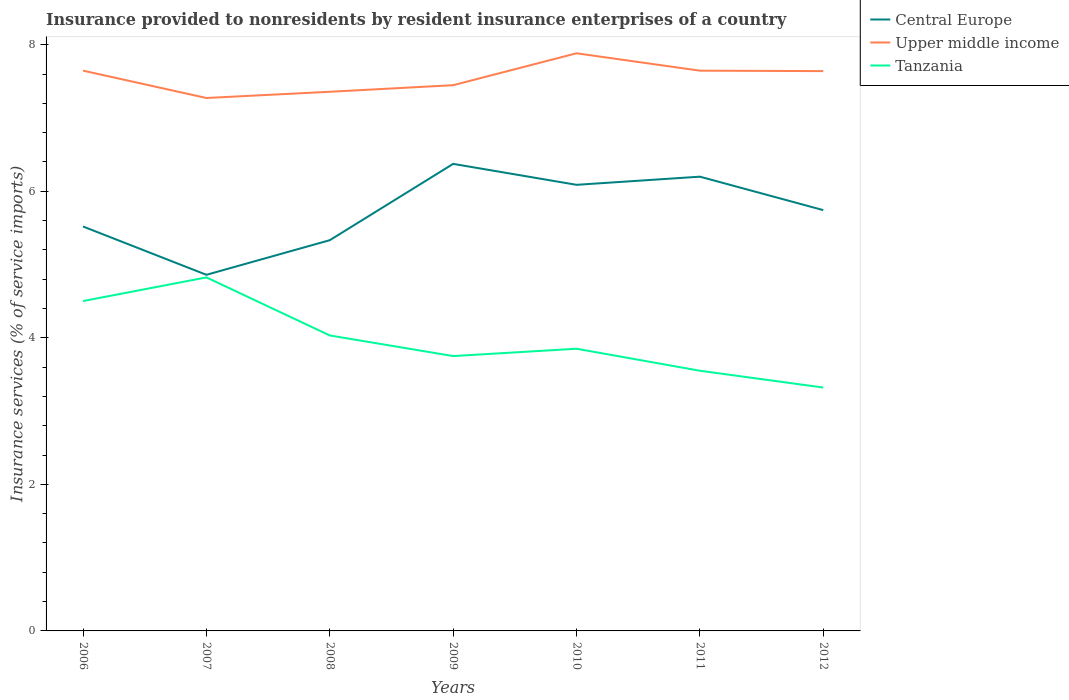How many different coloured lines are there?
Ensure brevity in your answer.  3. Is the number of lines equal to the number of legend labels?
Offer a very short reply. Yes. Across all years, what is the maximum insurance provided to nonresidents in Tanzania?
Offer a very short reply. 3.32. What is the total insurance provided to nonresidents in Upper middle income in the graph?
Give a very brief answer. -0.37. What is the difference between the highest and the second highest insurance provided to nonresidents in Upper middle income?
Your answer should be compact. 0.61. What is the difference between the highest and the lowest insurance provided to nonresidents in Upper middle income?
Provide a short and direct response. 4. How many years are there in the graph?
Make the answer very short. 7. Does the graph contain grids?
Offer a terse response. No. How many legend labels are there?
Provide a succinct answer. 3. How are the legend labels stacked?
Your answer should be compact. Vertical. What is the title of the graph?
Give a very brief answer. Insurance provided to nonresidents by resident insurance enterprises of a country. Does "Central Europe" appear as one of the legend labels in the graph?
Provide a short and direct response. Yes. What is the label or title of the X-axis?
Your answer should be very brief. Years. What is the label or title of the Y-axis?
Offer a terse response. Insurance services (% of service imports). What is the Insurance services (% of service imports) in Central Europe in 2006?
Keep it short and to the point. 5.52. What is the Insurance services (% of service imports) in Upper middle income in 2006?
Offer a terse response. 7.65. What is the Insurance services (% of service imports) in Tanzania in 2006?
Provide a short and direct response. 4.5. What is the Insurance services (% of service imports) of Central Europe in 2007?
Your response must be concise. 4.86. What is the Insurance services (% of service imports) of Upper middle income in 2007?
Ensure brevity in your answer.  7.27. What is the Insurance services (% of service imports) in Tanzania in 2007?
Ensure brevity in your answer.  4.82. What is the Insurance services (% of service imports) in Central Europe in 2008?
Give a very brief answer. 5.33. What is the Insurance services (% of service imports) of Upper middle income in 2008?
Ensure brevity in your answer.  7.36. What is the Insurance services (% of service imports) in Tanzania in 2008?
Your answer should be compact. 4.03. What is the Insurance services (% of service imports) in Central Europe in 2009?
Offer a terse response. 6.37. What is the Insurance services (% of service imports) of Upper middle income in 2009?
Give a very brief answer. 7.45. What is the Insurance services (% of service imports) of Tanzania in 2009?
Provide a succinct answer. 3.75. What is the Insurance services (% of service imports) in Central Europe in 2010?
Offer a very short reply. 6.09. What is the Insurance services (% of service imports) of Upper middle income in 2010?
Give a very brief answer. 7.88. What is the Insurance services (% of service imports) of Tanzania in 2010?
Offer a very short reply. 3.85. What is the Insurance services (% of service imports) of Central Europe in 2011?
Ensure brevity in your answer.  6.2. What is the Insurance services (% of service imports) in Upper middle income in 2011?
Offer a terse response. 7.65. What is the Insurance services (% of service imports) in Tanzania in 2011?
Your answer should be compact. 3.55. What is the Insurance services (% of service imports) in Central Europe in 2012?
Provide a short and direct response. 5.74. What is the Insurance services (% of service imports) of Upper middle income in 2012?
Offer a very short reply. 7.64. What is the Insurance services (% of service imports) in Tanzania in 2012?
Give a very brief answer. 3.32. Across all years, what is the maximum Insurance services (% of service imports) in Central Europe?
Provide a succinct answer. 6.37. Across all years, what is the maximum Insurance services (% of service imports) of Upper middle income?
Ensure brevity in your answer.  7.88. Across all years, what is the maximum Insurance services (% of service imports) in Tanzania?
Provide a succinct answer. 4.82. Across all years, what is the minimum Insurance services (% of service imports) in Central Europe?
Provide a short and direct response. 4.86. Across all years, what is the minimum Insurance services (% of service imports) of Upper middle income?
Your answer should be compact. 7.27. Across all years, what is the minimum Insurance services (% of service imports) in Tanzania?
Your answer should be very brief. 3.32. What is the total Insurance services (% of service imports) of Central Europe in the graph?
Offer a very short reply. 40.11. What is the total Insurance services (% of service imports) in Upper middle income in the graph?
Offer a very short reply. 52.89. What is the total Insurance services (% of service imports) in Tanzania in the graph?
Offer a very short reply. 27.83. What is the difference between the Insurance services (% of service imports) of Central Europe in 2006 and that in 2007?
Keep it short and to the point. 0.66. What is the difference between the Insurance services (% of service imports) in Upper middle income in 2006 and that in 2007?
Your answer should be very brief. 0.37. What is the difference between the Insurance services (% of service imports) of Tanzania in 2006 and that in 2007?
Offer a very short reply. -0.32. What is the difference between the Insurance services (% of service imports) of Central Europe in 2006 and that in 2008?
Your answer should be very brief. 0.19. What is the difference between the Insurance services (% of service imports) in Upper middle income in 2006 and that in 2008?
Provide a succinct answer. 0.29. What is the difference between the Insurance services (% of service imports) in Tanzania in 2006 and that in 2008?
Offer a very short reply. 0.47. What is the difference between the Insurance services (% of service imports) in Central Europe in 2006 and that in 2009?
Keep it short and to the point. -0.85. What is the difference between the Insurance services (% of service imports) of Upper middle income in 2006 and that in 2009?
Provide a short and direct response. 0.2. What is the difference between the Insurance services (% of service imports) in Tanzania in 2006 and that in 2009?
Give a very brief answer. 0.75. What is the difference between the Insurance services (% of service imports) of Central Europe in 2006 and that in 2010?
Your answer should be compact. -0.57. What is the difference between the Insurance services (% of service imports) of Upper middle income in 2006 and that in 2010?
Your answer should be compact. -0.24. What is the difference between the Insurance services (% of service imports) of Tanzania in 2006 and that in 2010?
Offer a terse response. 0.65. What is the difference between the Insurance services (% of service imports) in Central Europe in 2006 and that in 2011?
Your response must be concise. -0.68. What is the difference between the Insurance services (% of service imports) of Tanzania in 2006 and that in 2011?
Your answer should be compact. 0.95. What is the difference between the Insurance services (% of service imports) in Central Europe in 2006 and that in 2012?
Make the answer very short. -0.22. What is the difference between the Insurance services (% of service imports) of Upper middle income in 2006 and that in 2012?
Make the answer very short. 0.01. What is the difference between the Insurance services (% of service imports) in Tanzania in 2006 and that in 2012?
Ensure brevity in your answer.  1.18. What is the difference between the Insurance services (% of service imports) in Central Europe in 2007 and that in 2008?
Keep it short and to the point. -0.47. What is the difference between the Insurance services (% of service imports) of Upper middle income in 2007 and that in 2008?
Your response must be concise. -0.09. What is the difference between the Insurance services (% of service imports) of Tanzania in 2007 and that in 2008?
Provide a succinct answer. 0.79. What is the difference between the Insurance services (% of service imports) in Central Europe in 2007 and that in 2009?
Ensure brevity in your answer.  -1.51. What is the difference between the Insurance services (% of service imports) in Upper middle income in 2007 and that in 2009?
Your answer should be compact. -0.17. What is the difference between the Insurance services (% of service imports) in Tanzania in 2007 and that in 2009?
Your answer should be compact. 1.07. What is the difference between the Insurance services (% of service imports) in Central Europe in 2007 and that in 2010?
Provide a succinct answer. -1.23. What is the difference between the Insurance services (% of service imports) of Upper middle income in 2007 and that in 2010?
Ensure brevity in your answer.  -0.61. What is the difference between the Insurance services (% of service imports) of Tanzania in 2007 and that in 2010?
Your answer should be compact. 0.97. What is the difference between the Insurance services (% of service imports) of Central Europe in 2007 and that in 2011?
Provide a succinct answer. -1.34. What is the difference between the Insurance services (% of service imports) of Upper middle income in 2007 and that in 2011?
Your answer should be very brief. -0.37. What is the difference between the Insurance services (% of service imports) in Tanzania in 2007 and that in 2011?
Your answer should be very brief. 1.27. What is the difference between the Insurance services (% of service imports) in Central Europe in 2007 and that in 2012?
Make the answer very short. -0.88. What is the difference between the Insurance services (% of service imports) of Upper middle income in 2007 and that in 2012?
Keep it short and to the point. -0.37. What is the difference between the Insurance services (% of service imports) of Tanzania in 2007 and that in 2012?
Offer a terse response. 1.5. What is the difference between the Insurance services (% of service imports) in Central Europe in 2008 and that in 2009?
Give a very brief answer. -1.04. What is the difference between the Insurance services (% of service imports) in Upper middle income in 2008 and that in 2009?
Provide a succinct answer. -0.09. What is the difference between the Insurance services (% of service imports) in Tanzania in 2008 and that in 2009?
Keep it short and to the point. 0.28. What is the difference between the Insurance services (% of service imports) of Central Europe in 2008 and that in 2010?
Your answer should be compact. -0.76. What is the difference between the Insurance services (% of service imports) of Upper middle income in 2008 and that in 2010?
Offer a terse response. -0.53. What is the difference between the Insurance services (% of service imports) of Tanzania in 2008 and that in 2010?
Provide a short and direct response. 0.18. What is the difference between the Insurance services (% of service imports) of Central Europe in 2008 and that in 2011?
Keep it short and to the point. -0.87. What is the difference between the Insurance services (% of service imports) in Upper middle income in 2008 and that in 2011?
Give a very brief answer. -0.29. What is the difference between the Insurance services (% of service imports) of Tanzania in 2008 and that in 2011?
Provide a succinct answer. 0.48. What is the difference between the Insurance services (% of service imports) in Central Europe in 2008 and that in 2012?
Provide a succinct answer. -0.41. What is the difference between the Insurance services (% of service imports) in Upper middle income in 2008 and that in 2012?
Provide a succinct answer. -0.28. What is the difference between the Insurance services (% of service imports) in Tanzania in 2008 and that in 2012?
Your answer should be compact. 0.71. What is the difference between the Insurance services (% of service imports) in Central Europe in 2009 and that in 2010?
Provide a short and direct response. 0.29. What is the difference between the Insurance services (% of service imports) of Upper middle income in 2009 and that in 2010?
Your answer should be compact. -0.44. What is the difference between the Insurance services (% of service imports) in Central Europe in 2009 and that in 2011?
Give a very brief answer. 0.17. What is the difference between the Insurance services (% of service imports) in Upper middle income in 2009 and that in 2011?
Offer a terse response. -0.2. What is the difference between the Insurance services (% of service imports) of Tanzania in 2009 and that in 2011?
Your response must be concise. 0.2. What is the difference between the Insurance services (% of service imports) of Central Europe in 2009 and that in 2012?
Your answer should be very brief. 0.63. What is the difference between the Insurance services (% of service imports) in Upper middle income in 2009 and that in 2012?
Offer a terse response. -0.19. What is the difference between the Insurance services (% of service imports) of Tanzania in 2009 and that in 2012?
Your answer should be very brief. 0.43. What is the difference between the Insurance services (% of service imports) in Central Europe in 2010 and that in 2011?
Offer a very short reply. -0.11. What is the difference between the Insurance services (% of service imports) of Upper middle income in 2010 and that in 2011?
Offer a very short reply. 0.24. What is the difference between the Insurance services (% of service imports) of Tanzania in 2010 and that in 2011?
Provide a succinct answer. 0.3. What is the difference between the Insurance services (% of service imports) of Central Europe in 2010 and that in 2012?
Offer a very short reply. 0.35. What is the difference between the Insurance services (% of service imports) in Upper middle income in 2010 and that in 2012?
Offer a terse response. 0.24. What is the difference between the Insurance services (% of service imports) in Tanzania in 2010 and that in 2012?
Keep it short and to the point. 0.53. What is the difference between the Insurance services (% of service imports) in Central Europe in 2011 and that in 2012?
Your response must be concise. 0.46. What is the difference between the Insurance services (% of service imports) of Upper middle income in 2011 and that in 2012?
Your answer should be very brief. 0.01. What is the difference between the Insurance services (% of service imports) in Tanzania in 2011 and that in 2012?
Provide a short and direct response. 0.23. What is the difference between the Insurance services (% of service imports) of Central Europe in 2006 and the Insurance services (% of service imports) of Upper middle income in 2007?
Provide a short and direct response. -1.75. What is the difference between the Insurance services (% of service imports) in Central Europe in 2006 and the Insurance services (% of service imports) in Tanzania in 2007?
Provide a short and direct response. 0.69. What is the difference between the Insurance services (% of service imports) in Upper middle income in 2006 and the Insurance services (% of service imports) in Tanzania in 2007?
Give a very brief answer. 2.82. What is the difference between the Insurance services (% of service imports) in Central Europe in 2006 and the Insurance services (% of service imports) in Upper middle income in 2008?
Ensure brevity in your answer.  -1.84. What is the difference between the Insurance services (% of service imports) of Central Europe in 2006 and the Insurance services (% of service imports) of Tanzania in 2008?
Ensure brevity in your answer.  1.49. What is the difference between the Insurance services (% of service imports) in Upper middle income in 2006 and the Insurance services (% of service imports) in Tanzania in 2008?
Your answer should be compact. 3.61. What is the difference between the Insurance services (% of service imports) of Central Europe in 2006 and the Insurance services (% of service imports) of Upper middle income in 2009?
Your response must be concise. -1.93. What is the difference between the Insurance services (% of service imports) in Central Europe in 2006 and the Insurance services (% of service imports) in Tanzania in 2009?
Your answer should be very brief. 1.77. What is the difference between the Insurance services (% of service imports) in Upper middle income in 2006 and the Insurance services (% of service imports) in Tanzania in 2009?
Your response must be concise. 3.9. What is the difference between the Insurance services (% of service imports) in Central Europe in 2006 and the Insurance services (% of service imports) in Upper middle income in 2010?
Provide a succinct answer. -2.36. What is the difference between the Insurance services (% of service imports) in Central Europe in 2006 and the Insurance services (% of service imports) in Tanzania in 2010?
Provide a short and direct response. 1.67. What is the difference between the Insurance services (% of service imports) of Upper middle income in 2006 and the Insurance services (% of service imports) of Tanzania in 2010?
Provide a succinct answer. 3.79. What is the difference between the Insurance services (% of service imports) in Central Europe in 2006 and the Insurance services (% of service imports) in Upper middle income in 2011?
Provide a succinct answer. -2.13. What is the difference between the Insurance services (% of service imports) of Central Europe in 2006 and the Insurance services (% of service imports) of Tanzania in 2011?
Provide a succinct answer. 1.97. What is the difference between the Insurance services (% of service imports) of Upper middle income in 2006 and the Insurance services (% of service imports) of Tanzania in 2011?
Provide a succinct answer. 4.1. What is the difference between the Insurance services (% of service imports) of Central Europe in 2006 and the Insurance services (% of service imports) of Upper middle income in 2012?
Offer a very short reply. -2.12. What is the difference between the Insurance services (% of service imports) in Central Europe in 2006 and the Insurance services (% of service imports) in Tanzania in 2012?
Your answer should be very brief. 2.2. What is the difference between the Insurance services (% of service imports) in Upper middle income in 2006 and the Insurance services (% of service imports) in Tanzania in 2012?
Offer a terse response. 4.32. What is the difference between the Insurance services (% of service imports) of Central Europe in 2007 and the Insurance services (% of service imports) of Upper middle income in 2008?
Offer a terse response. -2.5. What is the difference between the Insurance services (% of service imports) of Central Europe in 2007 and the Insurance services (% of service imports) of Tanzania in 2008?
Provide a succinct answer. 0.83. What is the difference between the Insurance services (% of service imports) of Upper middle income in 2007 and the Insurance services (% of service imports) of Tanzania in 2008?
Keep it short and to the point. 3.24. What is the difference between the Insurance services (% of service imports) of Central Europe in 2007 and the Insurance services (% of service imports) of Upper middle income in 2009?
Provide a succinct answer. -2.59. What is the difference between the Insurance services (% of service imports) of Central Europe in 2007 and the Insurance services (% of service imports) of Tanzania in 2009?
Offer a terse response. 1.11. What is the difference between the Insurance services (% of service imports) of Upper middle income in 2007 and the Insurance services (% of service imports) of Tanzania in 2009?
Offer a very short reply. 3.52. What is the difference between the Insurance services (% of service imports) of Central Europe in 2007 and the Insurance services (% of service imports) of Upper middle income in 2010?
Provide a short and direct response. -3.02. What is the difference between the Insurance services (% of service imports) in Central Europe in 2007 and the Insurance services (% of service imports) in Tanzania in 2010?
Offer a very short reply. 1.01. What is the difference between the Insurance services (% of service imports) of Upper middle income in 2007 and the Insurance services (% of service imports) of Tanzania in 2010?
Your answer should be compact. 3.42. What is the difference between the Insurance services (% of service imports) of Central Europe in 2007 and the Insurance services (% of service imports) of Upper middle income in 2011?
Keep it short and to the point. -2.79. What is the difference between the Insurance services (% of service imports) of Central Europe in 2007 and the Insurance services (% of service imports) of Tanzania in 2011?
Offer a terse response. 1.31. What is the difference between the Insurance services (% of service imports) in Upper middle income in 2007 and the Insurance services (% of service imports) in Tanzania in 2011?
Your answer should be very brief. 3.72. What is the difference between the Insurance services (% of service imports) in Central Europe in 2007 and the Insurance services (% of service imports) in Upper middle income in 2012?
Your response must be concise. -2.78. What is the difference between the Insurance services (% of service imports) of Central Europe in 2007 and the Insurance services (% of service imports) of Tanzania in 2012?
Make the answer very short. 1.54. What is the difference between the Insurance services (% of service imports) in Upper middle income in 2007 and the Insurance services (% of service imports) in Tanzania in 2012?
Your answer should be very brief. 3.95. What is the difference between the Insurance services (% of service imports) of Central Europe in 2008 and the Insurance services (% of service imports) of Upper middle income in 2009?
Your answer should be compact. -2.12. What is the difference between the Insurance services (% of service imports) of Central Europe in 2008 and the Insurance services (% of service imports) of Tanzania in 2009?
Provide a short and direct response. 1.58. What is the difference between the Insurance services (% of service imports) of Upper middle income in 2008 and the Insurance services (% of service imports) of Tanzania in 2009?
Provide a succinct answer. 3.61. What is the difference between the Insurance services (% of service imports) in Central Europe in 2008 and the Insurance services (% of service imports) in Upper middle income in 2010?
Offer a terse response. -2.55. What is the difference between the Insurance services (% of service imports) of Central Europe in 2008 and the Insurance services (% of service imports) of Tanzania in 2010?
Provide a succinct answer. 1.48. What is the difference between the Insurance services (% of service imports) of Upper middle income in 2008 and the Insurance services (% of service imports) of Tanzania in 2010?
Your answer should be compact. 3.51. What is the difference between the Insurance services (% of service imports) of Central Europe in 2008 and the Insurance services (% of service imports) of Upper middle income in 2011?
Your answer should be compact. -2.31. What is the difference between the Insurance services (% of service imports) in Central Europe in 2008 and the Insurance services (% of service imports) in Tanzania in 2011?
Give a very brief answer. 1.78. What is the difference between the Insurance services (% of service imports) of Upper middle income in 2008 and the Insurance services (% of service imports) of Tanzania in 2011?
Your answer should be compact. 3.81. What is the difference between the Insurance services (% of service imports) in Central Europe in 2008 and the Insurance services (% of service imports) in Upper middle income in 2012?
Offer a very short reply. -2.31. What is the difference between the Insurance services (% of service imports) of Central Europe in 2008 and the Insurance services (% of service imports) of Tanzania in 2012?
Provide a short and direct response. 2.01. What is the difference between the Insurance services (% of service imports) of Upper middle income in 2008 and the Insurance services (% of service imports) of Tanzania in 2012?
Offer a terse response. 4.04. What is the difference between the Insurance services (% of service imports) in Central Europe in 2009 and the Insurance services (% of service imports) in Upper middle income in 2010?
Keep it short and to the point. -1.51. What is the difference between the Insurance services (% of service imports) of Central Europe in 2009 and the Insurance services (% of service imports) of Tanzania in 2010?
Provide a short and direct response. 2.52. What is the difference between the Insurance services (% of service imports) of Upper middle income in 2009 and the Insurance services (% of service imports) of Tanzania in 2010?
Your answer should be compact. 3.6. What is the difference between the Insurance services (% of service imports) of Central Europe in 2009 and the Insurance services (% of service imports) of Upper middle income in 2011?
Your response must be concise. -1.27. What is the difference between the Insurance services (% of service imports) in Central Europe in 2009 and the Insurance services (% of service imports) in Tanzania in 2011?
Your answer should be compact. 2.82. What is the difference between the Insurance services (% of service imports) of Upper middle income in 2009 and the Insurance services (% of service imports) of Tanzania in 2011?
Your response must be concise. 3.9. What is the difference between the Insurance services (% of service imports) of Central Europe in 2009 and the Insurance services (% of service imports) of Upper middle income in 2012?
Your response must be concise. -1.27. What is the difference between the Insurance services (% of service imports) in Central Europe in 2009 and the Insurance services (% of service imports) in Tanzania in 2012?
Ensure brevity in your answer.  3.05. What is the difference between the Insurance services (% of service imports) of Upper middle income in 2009 and the Insurance services (% of service imports) of Tanzania in 2012?
Give a very brief answer. 4.13. What is the difference between the Insurance services (% of service imports) in Central Europe in 2010 and the Insurance services (% of service imports) in Upper middle income in 2011?
Provide a short and direct response. -1.56. What is the difference between the Insurance services (% of service imports) of Central Europe in 2010 and the Insurance services (% of service imports) of Tanzania in 2011?
Offer a very short reply. 2.54. What is the difference between the Insurance services (% of service imports) in Upper middle income in 2010 and the Insurance services (% of service imports) in Tanzania in 2011?
Your answer should be very brief. 4.33. What is the difference between the Insurance services (% of service imports) in Central Europe in 2010 and the Insurance services (% of service imports) in Upper middle income in 2012?
Provide a succinct answer. -1.55. What is the difference between the Insurance services (% of service imports) in Central Europe in 2010 and the Insurance services (% of service imports) in Tanzania in 2012?
Offer a terse response. 2.77. What is the difference between the Insurance services (% of service imports) in Upper middle income in 2010 and the Insurance services (% of service imports) in Tanzania in 2012?
Provide a short and direct response. 4.56. What is the difference between the Insurance services (% of service imports) in Central Europe in 2011 and the Insurance services (% of service imports) in Upper middle income in 2012?
Ensure brevity in your answer.  -1.44. What is the difference between the Insurance services (% of service imports) of Central Europe in 2011 and the Insurance services (% of service imports) of Tanzania in 2012?
Your answer should be compact. 2.88. What is the difference between the Insurance services (% of service imports) in Upper middle income in 2011 and the Insurance services (% of service imports) in Tanzania in 2012?
Keep it short and to the point. 4.32. What is the average Insurance services (% of service imports) in Central Europe per year?
Ensure brevity in your answer.  5.73. What is the average Insurance services (% of service imports) of Upper middle income per year?
Provide a succinct answer. 7.56. What is the average Insurance services (% of service imports) in Tanzania per year?
Keep it short and to the point. 3.98. In the year 2006, what is the difference between the Insurance services (% of service imports) of Central Europe and Insurance services (% of service imports) of Upper middle income?
Your answer should be very brief. -2.13. In the year 2006, what is the difference between the Insurance services (% of service imports) of Central Europe and Insurance services (% of service imports) of Tanzania?
Your answer should be very brief. 1.02. In the year 2006, what is the difference between the Insurance services (% of service imports) in Upper middle income and Insurance services (% of service imports) in Tanzania?
Offer a very short reply. 3.14. In the year 2007, what is the difference between the Insurance services (% of service imports) in Central Europe and Insurance services (% of service imports) in Upper middle income?
Make the answer very short. -2.41. In the year 2007, what is the difference between the Insurance services (% of service imports) in Central Europe and Insurance services (% of service imports) in Tanzania?
Your response must be concise. 0.04. In the year 2007, what is the difference between the Insurance services (% of service imports) in Upper middle income and Insurance services (% of service imports) in Tanzania?
Ensure brevity in your answer.  2.45. In the year 2008, what is the difference between the Insurance services (% of service imports) of Central Europe and Insurance services (% of service imports) of Upper middle income?
Your answer should be compact. -2.03. In the year 2008, what is the difference between the Insurance services (% of service imports) in Central Europe and Insurance services (% of service imports) in Tanzania?
Your answer should be very brief. 1.3. In the year 2008, what is the difference between the Insurance services (% of service imports) in Upper middle income and Insurance services (% of service imports) in Tanzania?
Your response must be concise. 3.33. In the year 2009, what is the difference between the Insurance services (% of service imports) of Central Europe and Insurance services (% of service imports) of Upper middle income?
Your response must be concise. -1.07. In the year 2009, what is the difference between the Insurance services (% of service imports) of Central Europe and Insurance services (% of service imports) of Tanzania?
Your answer should be very brief. 2.62. In the year 2009, what is the difference between the Insurance services (% of service imports) in Upper middle income and Insurance services (% of service imports) in Tanzania?
Your answer should be compact. 3.7. In the year 2010, what is the difference between the Insurance services (% of service imports) in Central Europe and Insurance services (% of service imports) in Upper middle income?
Provide a short and direct response. -1.79. In the year 2010, what is the difference between the Insurance services (% of service imports) in Central Europe and Insurance services (% of service imports) in Tanzania?
Provide a short and direct response. 2.24. In the year 2010, what is the difference between the Insurance services (% of service imports) in Upper middle income and Insurance services (% of service imports) in Tanzania?
Offer a very short reply. 4.03. In the year 2011, what is the difference between the Insurance services (% of service imports) of Central Europe and Insurance services (% of service imports) of Upper middle income?
Make the answer very short. -1.45. In the year 2011, what is the difference between the Insurance services (% of service imports) in Central Europe and Insurance services (% of service imports) in Tanzania?
Make the answer very short. 2.65. In the year 2011, what is the difference between the Insurance services (% of service imports) in Upper middle income and Insurance services (% of service imports) in Tanzania?
Ensure brevity in your answer.  4.1. In the year 2012, what is the difference between the Insurance services (% of service imports) of Central Europe and Insurance services (% of service imports) of Upper middle income?
Keep it short and to the point. -1.9. In the year 2012, what is the difference between the Insurance services (% of service imports) in Central Europe and Insurance services (% of service imports) in Tanzania?
Offer a very short reply. 2.42. In the year 2012, what is the difference between the Insurance services (% of service imports) in Upper middle income and Insurance services (% of service imports) in Tanzania?
Provide a succinct answer. 4.32. What is the ratio of the Insurance services (% of service imports) of Central Europe in 2006 to that in 2007?
Give a very brief answer. 1.14. What is the ratio of the Insurance services (% of service imports) of Upper middle income in 2006 to that in 2007?
Ensure brevity in your answer.  1.05. What is the ratio of the Insurance services (% of service imports) of Tanzania in 2006 to that in 2007?
Keep it short and to the point. 0.93. What is the ratio of the Insurance services (% of service imports) of Central Europe in 2006 to that in 2008?
Your answer should be compact. 1.04. What is the ratio of the Insurance services (% of service imports) of Upper middle income in 2006 to that in 2008?
Make the answer very short. 1.04. What is the ratio of the Insurance services (% of service imports) of Tanzania in 2006 to that in 2008?
Keep it short and to the point. 1.12. What is the ratio of the Insurance services (% of service imports) in Central Europe in 2006 to that in 2009?
Your answer should be compact. 0.87. What is the ratio of the Insurance services (% of service imports) of Upper middle income in 2006 to that in 2009?
Your answer should be compact. 1.03. What is the ratio of the Insurance services (% of service imports) in Tanzania in 2006 to that in 2009?
Provide a succinct answer. 1.2. What is the ratio of the Insurance services (% of service imports) of Central Europe in 2006 to that in 2010?
Your answer should be compact. 0.91. What is the ratio of the Insurance services (% of service imports) of Upper middle income in 2006 to that in 2010?
Offer a terse response. 0.97. What is the ratio of the Insurance services (% of service imports) of Tanzania in 2006 to that in 2010?
Provide a short and direct response. 1.17. What is the ratio of the Insurance services (% of service imports) in Central Europe in 2006 to that in 2011?
Keep it short and to the point. 0.89. What is the ratio of the Insurance services (% of service imports) in Upper middle income in 2006 to that in 2011?
Keep it short and to the point. 1. What is the ratio of the Insurance services (% of service imports) in Tanzania in 2006 to that in 2011?
Provide a short and direct response. 1.27. What is the ratio of the Insurance services (% of service imports) of Central Europe in 2006 to that in 2012?
Provide a short and direct response. 0.96. What is the ratio of the Insurance services (% of service imports) of Tanzania in 2006 to that in 2012?
Provide a succinct answer. 1.36. What is the ratio of the Insurance services (% of service imports) in Central Europe in 2007 to that in 2008?
Keep it short and to the point. 0.91. What is the ratio of the Insurance services (% of service imports) in Tanzania in 2007 to that in 2008?
Offer a terse response. 1.2. What is the ratio of the Insurance services (% of service imports) of Central Europe in 2007 to that in 2009?
Offer a very short reply. 0.76. What is the ratio of the Insurance services (% of service imports) of Upper middle income in 2007 to that in 2009?
Provide a succinct answer. 0.98. What is the ratio of the Insurance services (% of service imports) in Tanzania in 2007 to that in 2009?
Give a very brief answer. 1.29. What is the ratio of the Insurance services (% of service imports) in Central Europe in 2007 to that in 2010?
Provide a short and direct response. 0.8. What is the ratio of the Insurance services (% of service imports) of Upper middle income in 2007 to that in 2010?
Provide a short and direct response. 0.92. What is the ratio of the Insurance services (% of service imports) of Tanzania in 2007 to that in 2010?
Keep it short and to the point. 1.25. What is the ratio of the Insurance services (% of service imports) in Central Europe in 2007 to that in 2011?
Give a very brief answer. 0.78. What is the ratio of the Insurance services (% of service imports) in Upper middle income in 2007 to that in 2011?
Your answer should be compact. 0.95. What is the ratio of the Insurance services (% of service imports) in Tanzania in 2007 to that in 2011?
Provide a short and direct response. 1.36. What is the ratio of the Insurance services (% of service imports) in Central Europe in 2007 to that in 2012?
Keep it short and to the point. 0.85. What is the ratio of the Insurance services (% of service imports) in Upper middle income in 2007 to that in 2012?
Your answer should be very brief. 0.95. What is the ratio of the Insurance services (% of service imports) of Tanzania in 2007 to that in 2012?
Your answer should be compact. 1.45. What is the ratio of the Insurance services (% of service imports) of Central Europe in 2008 to that in 2009?
Give a very brief answer. 0.84. What is the ratio of the Insurance services (% of service imports) of Upper middle income in 2008 to that in 2009?
Give a very brief answer. 0.99. What is the ratio of the Insurance services (% of service imports) in Tanzania in 2008 to that in 2009?
Give a very brief answer. 1.07. What is the ratio of the Insurance services (% of service imports) of Central Europe in 2008 to that in 2010?
Ensure brevity in your answer.  0.88. What is the ratio of the Insurance services (% of service imports) of Upper middle income in 2008 to that in 2010?
Offer a terse response. 0.93. What is the ratio of the Insurance services (% of service imports) of Tanzania in 2008 to that in 2010?
Your answer should be compact. 1.05. What is the ratio of the Insurance services (% of service imports) in Central Europe in 2008 to that in 2011?
Your response must be concise. 0.86. What is the ratio of the Insurance services (% of service imports) of Upper middle income in 2008 to that in 2011?
Provide a succinct answer. 0.96. What is the ratio of the Insurance services (% of service imports) of Tanzania in 2008 to that in 2011?
Give a very brief answer. 1.14. What is the ratio of the Insurance services (% of service imports) of Central Europe in 2008 to that in 2012?
Your response must be concise. 0.93. What is the ratio of the Insurance services (% of service imports) of Upper middle income in 2008 to that in 2012?
Ensure brevity in your answer.  0.96. What is the ratio of the Insurance services (% of service imports) of Tanzania in 2008 to that in 2012?
Offer a very short reply. 1.21. What is the ratio of the Insurance services (% of service imports) in Central Europe in 2009 to that in 2010?
Offer a very short reply. 1.05. What is the ratio of the Insurance services (% of service imports) in Upper middle income in 2009 to that in 2010?
Offer a terse response. 0.94. What is the ratio of the Insurance services (% of service imports) in Central Europe in 2009 to that in 2011?
Give a very brief answer. 1.03. What is the ratio of the Insurance services (% of service imports) in Upper middle income in 2009 to that in 2011?
Your answer should be compact. 0.97. What is the ratio of the Insurance services (% of service imports) of Tanzania in 2009 to that in 2011?
Provide a succinct answer. 1.06. What is the ratio of the Insurance services (% of service imports) of Central Europe in 2009 to that in 2012?
Provide a short and direct response. 1.11. What is the ratio of the Insurance services (% of service imports) of Upper middle income in 2009 to that in 2012?
Make the answer very short. 0.97. What is the ratio of the Insurance services (% of service imports) in Tanzania in 2009 to that in 2012?
Your answer should be compact. 1.13. What is the ratio of the Insurance services (% of service imports) of Central Europe in 2010 to that in 2011?
Keep it short and to the point. 0.98. What is the ratio of the Insurance services (% of service imports) in Upper middle income in 2010 to that in 2011?
Ensure brevity in your answer.  1.03. What is the ratio of the Insurance services (% of service imports) of Tanzania in 2010 to that in 2011?
Your answer should be compact. 1.08. What is the ratio of the Insurance services (% of service imports) of Central Europe in 2010 to that in 2012?
Your response must be concise. 1.06. What is the ratio of the Insurance services (% of service imports) in Upper middle income in 2010 to that in 2012?
Offer a terse response. 1.03. What is the ratio of the Insurance services (% of service imports) in Tanzania in 2010 to that in 2012?
Offer a very short reply. 1.16. What is the ratio of the Insurance services (% of service imports) in Central Europe in 2011 to that in 2012?
Make the answer very short. 1.08. What is the ratio of the Insurance services (% of service imports) of Tanzania in 2011 to that in 2012?
Offer a terse response. 1.07. What is the difference between the highest and the second highest Insurance services (% of service imports) in Central Europe?
Your answer should be very brief. 0.17. What is the difference between the highest and the second highest Insurance services (% of service imports) in Upper middle income?
Your response must be concise. 0.24. What is the difference between the highest and the second highest Insurance services (% of service imports) of Tanzania?
Ensure brevity in your answer.  0.32. What is the difference between the highest and the lowest Insurance services (% of service imports) of Central Europe?
Provide a succinct answer. 1.51. What is the difference between the highest and the lowest Insurance services (% of service imports) in Upper middle income?
Make the answer very short. 0.61. What is the difference between the highest and the lowest Insurance services (% of service imports) in Tanzania?
Provide a short and direct response. 1.5. 